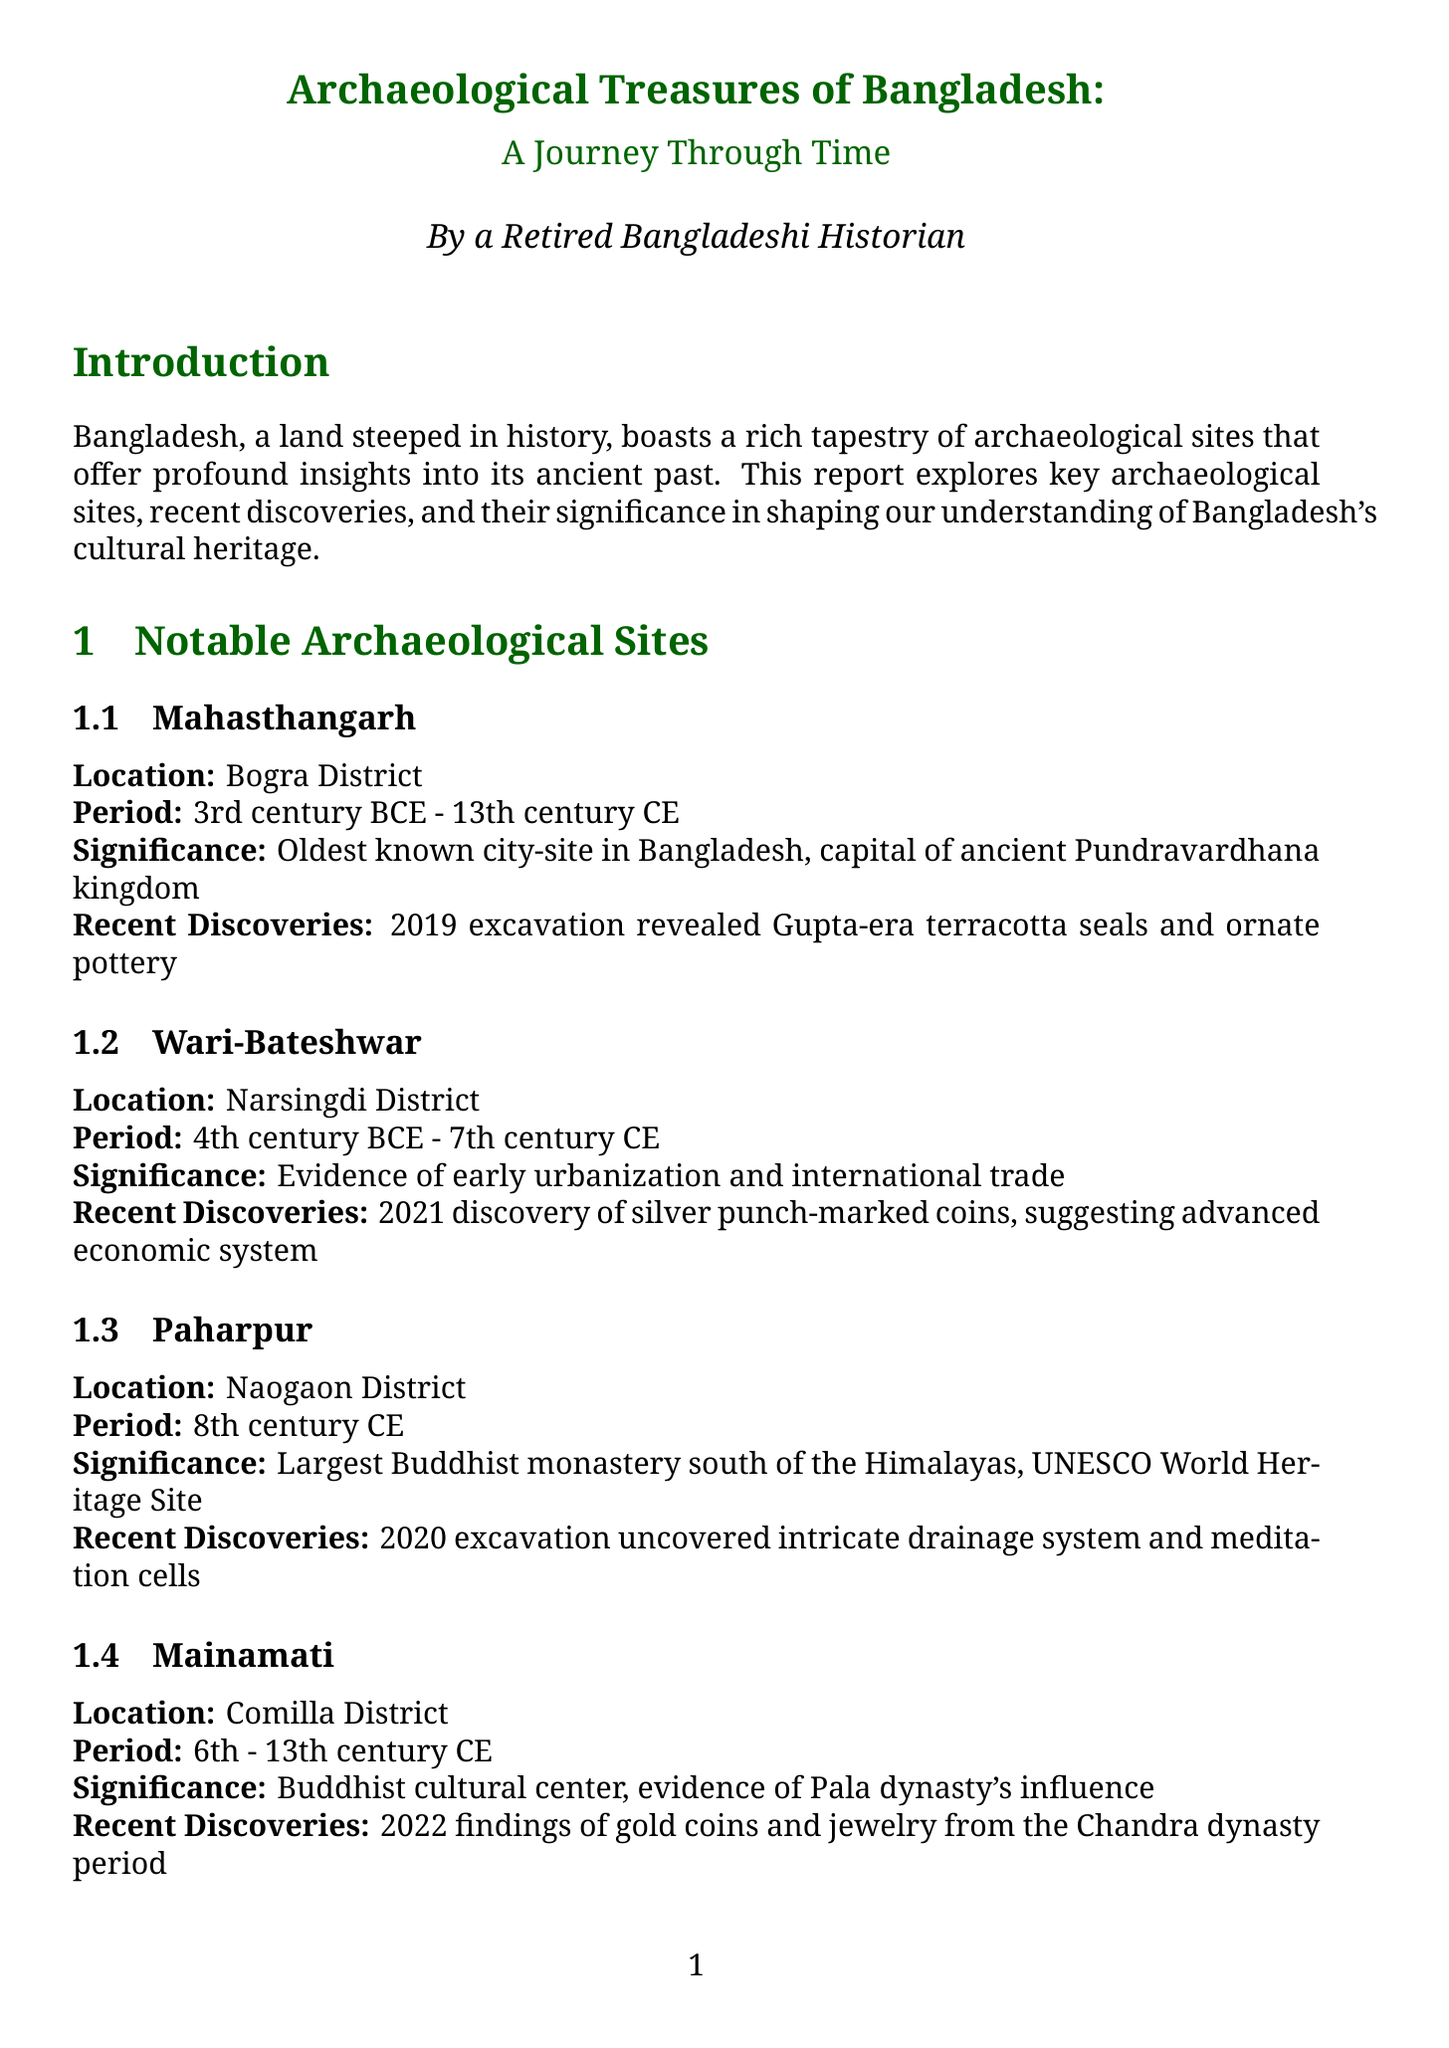What is the oldest known city-site in Bangladesh? The document states that Mahasthangarh is the oldest known city-site in Bangladesh, dating back to the Pundravardhana kingdom.
Answer: Mahasthangarh Where is Paharpur located? According to the report, Paharpur is located in Naogaon District.
Answer: Naogaon District What period does Wari-Bateshwar cover? The document specifies that Wari-Bateshwar spans from the 4th century BCE to the 7th century CE.
Answer: 4th century BCE - 7th century CE What recent discovery was made in Mainamati? The report mentions that the 2022 findings in Mainamati included gold coins and jewelry from the Chandra dynasty period.
Answer: Gold coins and jewelry Which UNESCO World Heritage Site is mentioned in the document? The document identifies Paharpur as the largest Buddhist monastery south of the Himalayas and a UNESCO World Heritage Site.
Answer: Paharpur What are the threats to archaeological sites listed in the report? The document lists urbanization, climate change, and lack of funding as threats to archaeological sites.
Answer: Urbanization, climate change, lack of funding What ongoing excavation is occurring in the Bay of Bengal? The document states that underwater archaeology is currently being conducted in the Bay of Bengal.
Answer: Underwater archaeology Which institution is responsible for excavations and preservation? The Department of Archaeology, Bangladesh is cited as the government body responsible for these tasks in the document.
Answer: Department of Archaeology, Bangladesh What is the significance of archaeological sites to national identity? The report highlights that archaeological sites provide tangible links to Bangladesh's rich cultural past.
Answer: Tangible links to cultural past 